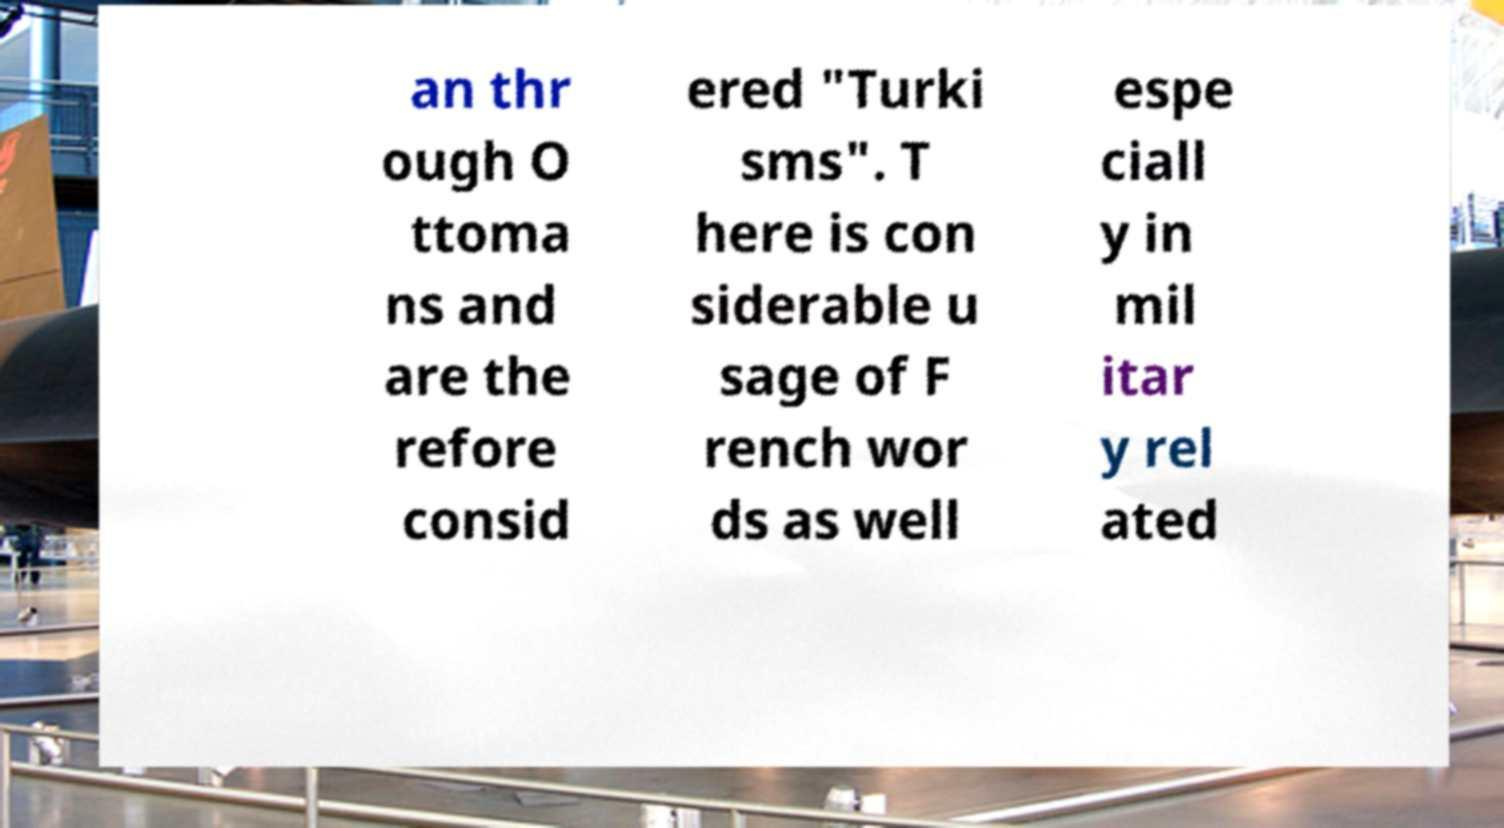For documentation purposes, I need the text within this image transcribed. Could you provide that? an thr ough O ttoma ns and are the refore consid ered "Turki sms". T here is con siderable u sage of F rench wor ds as well espe ciall y in mil itar y rel ated 